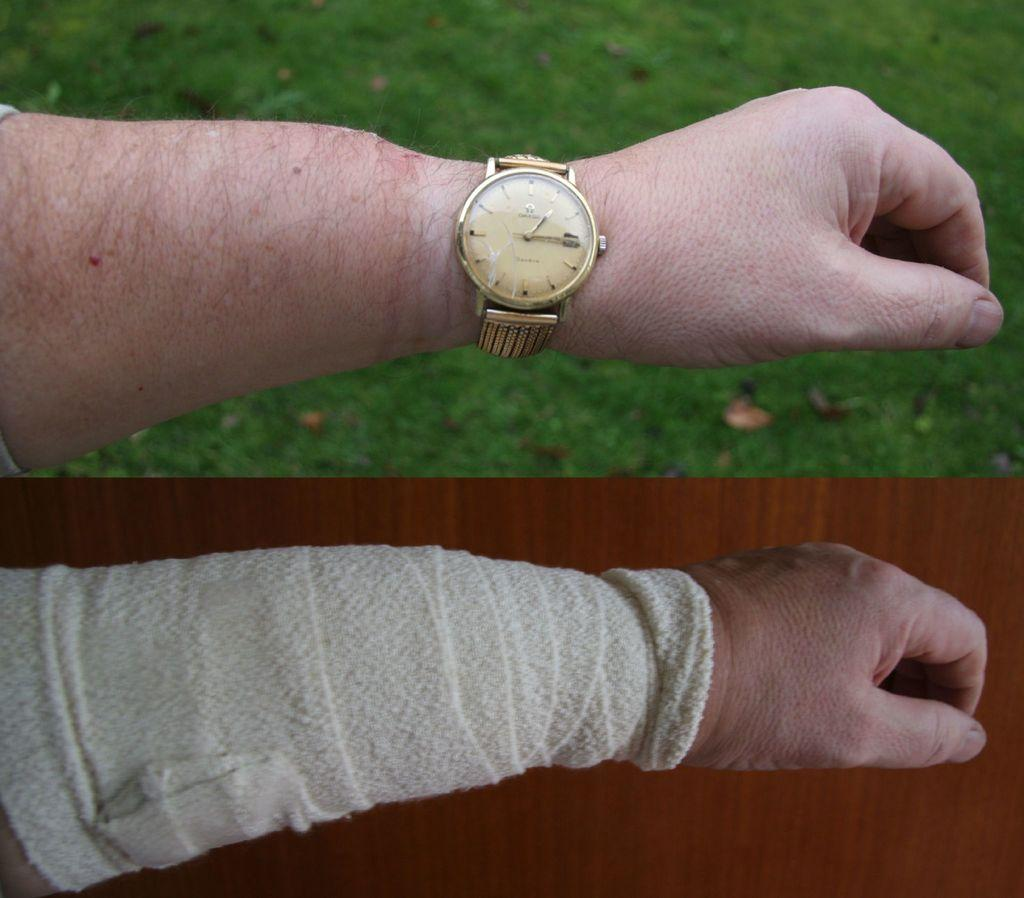What type of picture is shown in the image? The image contains a collage picture. Can you describe any specific elements within the collage picture? A person's hand is visible in the collage picture. What colors are used for the background in the collage picture? There is a green background and a brown background in the collage picture. What type of crib is visible in the image? There is no crib present in the image; it features a collage picture with a person's hand and green and brown backgrounds. How many flames can be seen in the image? There are no flames present in the image. 